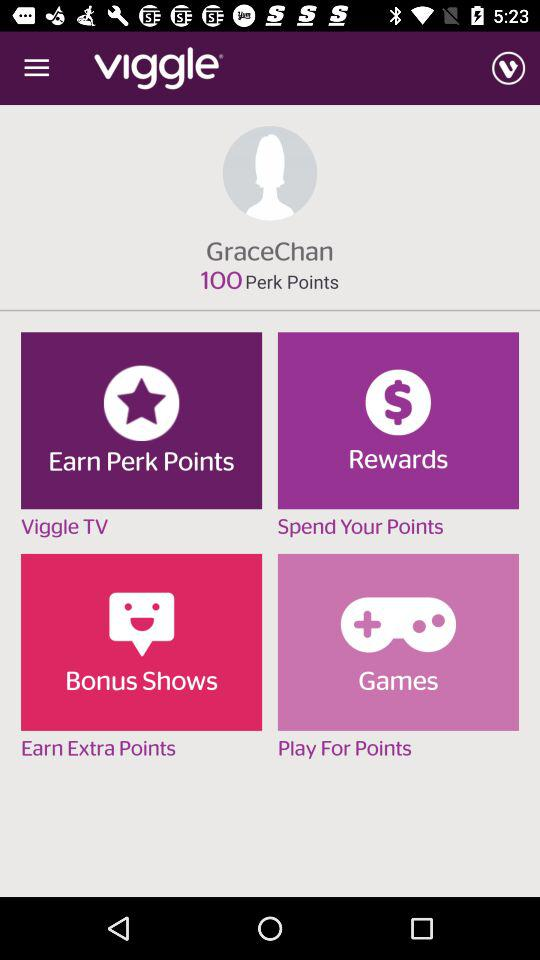How many points do I have in total?
Answer the question using a single word or phrase. 100 